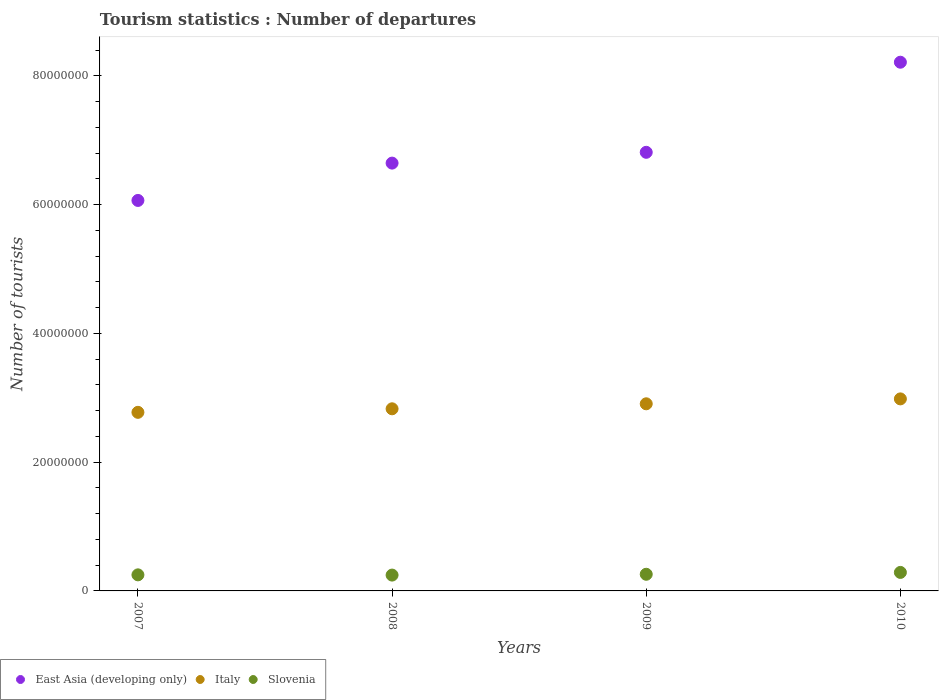How many different coloured dotlines are there?
Keep it short and to the point. 3. What is the number of tourist departures in East Asia (developing only) in 2009?
Ensure brevity in your answer.  6.81e+07. Across all years, what is the maximum number of tourist departures in Slovenia?
Your response must be concise. 2.87e+06. Across all years, what is the minimum number of tourist departures in Slovenia?
Keep it short and to the point. 2.46e+06. In which year was the number of tourist departures in Slovenia maximum?
Your answer should be compact. 2010. What is the total number of tourist departures in Slovenia in the graph?
Your answer should be very brief. 1.04e+07. What is the difference between the number of tourist departures in East Asia (developing only) in 2007 and that in 2010?
Ensure brevity in your answer.  -2.15e+07. What is the difference between the number of tourist departures in Italy in 2009 and the number of tourist departures in East Asia (developing only) in 2007?
Ensure brevity in your answer.  -3.16e+07. What is the average number of tourist departures in Italy per year?
Make the answer very short. 2.87e+07. In the year 2009, what is the difference between the number of tourist departures in East Asia (developing only) and number of tourist departures in Slovenia?
Your answer should be very brief. 6.55e+07. In how many years, is the number of tourist departures in Italy greater than 4000000?
Your response must be concise. 4. What is the ratio of the number of tourist departures in East Asia (developing only) in 2008 to that in 2009?
Offer a terse response. 0.98. Is the difference between the number of tourist departures in East Asia (developing only) in 2007 and 2008 greater than the difference between the number of tourist departures in Slovenia in 2007 and 2008?
Your answer should be very brief. No. What is the difference between the highest and the second highest number of tourist departures in Italy?
Give a very brief answer. 7.63e+05. What is the difference between the highest and the lowest number of tourist departures in East Asia (developing only)?
Your answer should be compact. 2.15e+07. In how many years, is the number of tourist departures in Italy greater than the average number of tourist departures in Italy taken over all years?
Provide a succinct answer. 2. Is the sum of the number of tourist departures in East Asia (developing only) in 2008 and 2010 greater than the maximum number of tourist departures in Italy across all years?
Offer a very short reply. Yes. Is it the case that in every year, the sum of the number of tourist departures in East Asia (developing only) and number of tourist departures in Slovenia  is greater than the number of tourist departures in Italy?
Your answer should be very brief. Yes. Is the number of tourist departures in East Asia (developing only) strictly less than the number of tourist departures in Slovenia over the years?
Your answer should be very brief. No. Where does the legend appear in the graph?
Keep it short and to the point. Bottom left. How are the legend labels stacked?
Ensure brevity in your answer.  Horizontal. What is the title of the graph?
Offer a terse response. Tourism statistics : Number of departures. Does "Fragile and conflict affected situations" appear as one of the legend labels in the graph?
Make the answer very short. No. What is the label or title of the Y-axis?
Make the answer very short. Number of tourists. What is the Number of tourists of East Asia (developing only) in 2007?
Offer a very short reply. 6.06e+07. What is the Number of tourists of Italy in 2007?
Offer a terse response. 2.77e+07. What is the Number of tourists in Slovenia in 2007?
Ensure brevity in your answer.  2.50e+06. What is the Number of tourists in East Asia (developing only) in 2008?
Your response must be concise. 6.64e+07. What is the Number of tourists in Italy in 2008?
Keep it short and to the point. 2.83e+07. What is the Number of tourists in Slovenia in 2008?
Offer a very short reply. 2.46e+06. What is the Number of tourists in East Asia (developing only) in 2009?
Offer a very short reply. 6.81e+07. What is the Number of tourists of Italy in 2009?
Keep it short and to the point. 2.91e+07. What is the Number of tourists of Slovenia in 2009?
Make the answer very short. 2.59e+06. What is the Number of tourists in East Asia (developing only) in 2010?
Your answer should be compact. 8.21e+07. What is the Number of tourists in Italy in 2010?
Provide a succinct answer. 2.98e+07. What is the Number of tourists in Slovenia in 2010?
Keep it short and to the point. 2.87e+06. Across all years, what is the maximum Number of tourists of East Asia (developing only)?
Offer a very short reply. 8.21e+07. Across all years, what is the maximum Number of tourists of Italy?
Ensure brevity in your answer.  2.98e+07. Across all years, what is the maximum Number of tourists in Slovenia?
Your answer should be very brief. 2.87e+06. Across all years, what is the minimum Number of tourists in East Asia (developing only)?
Offer a very short reply. 6.06e+07. Across all years, what is the minimum Number of tourists in Italy?
Make the answer very short. 2.77e+07. Across all years, what is the minimum Number of tourists in Slovenia?
Provide a succinct answer. 2.46e+06. What is the total Number of tourists in East Asia (developing only) in the graph?
Give a very brief answer. 2.77e+08. What is the total Number of tourists of Italy in the graph?
Provide a succinct answer. 1.15e+08. What is the total Number of tourists of Slovenia in the graph?
Offer a terse response. 1.04e+07. What is the difference between the Number of tourists in East Asia (developing only) in 2007 and that in 2008?
Your response must be concise. -5.80e+06. What is the difference between the Number of tourists in Italy in 2007 and that in 2008?
Offer a terse response. -5.50e+05. What is the difference between the Number of tourists in Slovenia in 2007 and that in 2008?
Make the answer very short. 3.70e+04. What is the difference between the Number of tourists of East Asia (developing only) in 2007 and that in 2009?
Offer a terse response. -7.47e+06. What is the difference between the Number of tourists of Italy in 2007 and that in 2009?
Your answer should be very brief. -1.33e+06. What is the difference between the Number of tourists in Slovenia in 2007 and that in 2009?
Provide a succinct answer. -9.00e+04. What is the difference between the Number of tourists of East Asia (developing only) in 2007 and that in 2010?
Offer a very short reply. -2.15e+07. What is the difference between the Number of tourists in Italy in 2007 and that in 2010?
Your answer should be compact. -2.09e+06. What is the difference between the Number of tourists of Slovenia in 2007 and that in 2010?
Offer a very short reply. -3.78e+05. What is the difference between the Number of tourists of East Asia (developing only) in 2008 and that in 2009?
Give a very brief answer. -1.68e+06. What is the difference between the Number of tourists in Italy in 2008 and that in 2009?
Your response must be concise. -7.76e+05. What is the difference between the Number of tourists in Slovenia in 2008 and that in 2009?
Ensure brevity in your answer.  -1.27e+05. What is the difference between the Number of tourists of East Asia (developing only) in 2008 and that in 2010?
Offer a very short reply. -1.57e+07. What is the difference between the Number of tourists of Italy in 2008 and that in 2010?
Your response must be concise. -1.54e+06. What is the difference between the Number of tourists of Slovenia in 2008 and that in 2010?
Your answer should be compact. -4.15e+05. What is the difference between the Number of tourists in East Asia (developing only) in 2009 and that in 2010?
Keep it short and to the point. -1.40e+07. What is the difference between the Number of tourists in Italy in 2009 and that in 2010?
Your response must be concise. -7.63e+05. What is the difference between the Number of tourists of Slovenia in 2009 and that in 2010?
Provide a succinct answer. -2.88e+05. What is the difference between the Number of tourists of East Asia (developing only) in 2007 and the Number of tourists of Italy in 2008?
Offer a terse response. 3.24e+07. What is the difference between the Number of tourists of East Asia (developing only) in 2007 and the Number of tourists of Slovenia in 2008?
Provide a succinct answer. 5.82e+07. What is the difference between the Number of tourists of Italy in 2007 and the Number of tourists of Slovenia in 2008?
Your answer should be compact. 2.53e+07. What is the difference between the Number of tourists in East Asia (developing only) in 2007 and the Number of tourists in Italy in 2009?
Offer a very short reply. 3.16e+07. What is the difference between the Number of tourists in East Asia (developing only) in 2007 and the Number of tourists in Slovenia in 2009?
Offer a very short reply. 5.81e+07. What is the difference between the Number of tourists in Italy in 2007 and the Number of tourists in Slovenia in 2009?
Ensure brevity in your answer.  2.51e+07. What is the difference between the Number of tourists of East Asia (developing only) in 2007 and the Number of tourists of Italy in 2010?
Keep it short and to the point. 3.08e+07. What is the difference between the Number of tourists in East Asia (developing only) in 2007 and the Number of tourists in Slovenia in 2010?
Give a very brief answer. 5.78e+07. What is the difference between the Number of tourists in Italy in 2007 and the Number of tourists in Slovenia in 2010?
Offer a very short reply. 2.49e+07. What is the difference between the Number of tourists of East Asia (developing only) in 2008 and the Number of tourists of Italy in 2009?
Provide a succinct answer. 3.74e+07. What is the difference between the Number of tourists in East Asia (developing only) in 2008 and the Number of tourists in Slovenia in 2009?
Your answer should be compact. 6.39e+07. What is the difference between the Number of tourists in Italy in 2008 and the Number of tourists in Slovenia in 2009?
Give a very brief answer. 2.57e+07. What is the difference between the Number of tourists of East Asia (developing only) in 2008 and the Number of tourists of Italy in 2010?
Offer a terse response. 3.66e+07. What is the difference between the Number of tourists in East Asia (developing only) in 2008 and the Number of tourists in Slovenia in 2010?
Your answer should be very brief. 6.36e+07. What is the difference between the Number of tourists in Italy in 2008 and the Number of tourists in Slovenia in 2010?
Your answer should be compact. 2.54e+07. What is the difference between the Number of tourists of East Asia (developing only) in 2009 and the Number of tourists of Italy in 2010?
Your response must be concise. 3.83e+07. What is the difference between the Number of tourists of East Asia (developing only) in 2009 and the Number of tourists of Slovenia in 2010?
Provide a short and direct response. 6.52e+07. What is the difference between the Number of tourists of Italy in 2009 and the Number of tourists of Slovenia in 2010?
Your answer should be compact. 2.62e+07. What is the average Number of tourists in East Asia (developing only) per year?
Give a very brief answer. 6.93e+07. What is the average Number of tourists in Italy per year?
Your answer should be very brief. 2.87e+07. What is the average Number of tourists in Slovenia per year?
Offer a terse response. 2.60e+06. In the year 2007, what is the difference between the Number of tourists of East Asia (developing only) and Number of tourists of Italy?
Keep it short and to the point. 3.29e+07. In the year 2007, what is the difference between the Number of tourists in East Asia (developing only) and Number of tourists in Slovenia?
Offer a terse response. 5.81e+07. In the year 2007, what is the difference between the Number of tourists of Italy and Number of tourists of Slovenia?
Offer a terse response. 2.52e+07. In the year 2008, what is the difference between the Number of tourists of East Asia (developing only) and Number of tourists of Italy?
Your response must be concise. 3.82e+07. In the year 2008, what is the difference between the Number of tourists of East Asia (developing only) and Number of tourists of Slovenia?
Provide a short and direct response. 6.40e+07. In the year 2008, what is the difference between the Number of tourists of Italy and Number of tourists of Slovenia?
Give a very brief answer. 2.58e+07. In the year 2009, what is the difference between the Number of tourists in East Asia (developing only) and Number of tourists in Italy?
Give a very brief answer. 3.91e+07. In the year 2009, what is the difference between the Number of tourists of East Asia (developing only) and Number of tourists of Slovenia?
Your response must be concise. 6.55e+07. In the year 2009, what is the difference between the Number of tourists of Italy and Number of tourists of Slovenia?
Provide a succinct answer. 2.65e+07. In the year 2010, what is the difference between the Number of tourists of East Asia (developing only) and Number of tourists of Italy?
Your answer should be compact. 5.23e+07. In the year 2010, what is the difference between the Number of tourists in East Asia (developing only) and Number of tourists in Slovenia?
Give a very brief answer. 7.92e+07. In the year 2010, what is the difference between the Number of tourists in Italy and Number of tourists in Slovenia?
Keep it short and to the point. 2.69e+07. What is the ratio of the Number of tourists in East Asia (developing only) in 2007 to that in 2008?
Offer a very short reply. 0.91. What is the ratio of the Number of tourists of Italy in 2007 to that in 2008?
Offer a very short reply. 0.98. What is the ratio of the Number of tourists in Slovenia in 2007 to that in 2008?
Your answer should be compact. 1.01. What is the ratio of the Number of tourists of East Asia (developing only) in 2007 to that in 2009?
Give a very brief answer. 0.89. What is the ratio of the Number of tourists in Italy in 2007 to that in 2009?
Your response must be concise. 0.95. What is the ratio of the Number of tourists of Slovenia in 2007 to that in 2009?
Your response must be concise. 0.97. What is the ratio of the Number of tourists in East Asia (developing only) in 2007 to that in 2010?
Your answer should be very brief. 0.74. What is the ratio of the Number of tourists of Slovenia in 2007 to that in 2010?
Offer a very short reply. 0.87. What is the ratio of the Number of tourists of East Asia (developing only) in 2008 to that in 2009?
Ensure brevity in your answer.  0.98. What is the ratio of the Number of tourists in Italy in 2008 to that in 2009?
Provide a short and direct response. 0.97. What is the ratio of the Number of tourists in Slovenia in 2008 to that in 2009?
Your response must be concise. 0.95. What is the ratio of the Number of tourists of East Asia (developing only) in 2008 to that in 2010?
Your answer should be compact. 0.81. What is the ratio of the Number of tourists in Italy in 2008 to that in 2010?
Offer a very short reply. 0.95. What is the ratio of the Number of tourists in Slovenia in 2008 to that in 2010?
Keep it short and to the point. 0.86. What is the ratio of the Number of tourists in East Asia (developing only) in 2009 to that in 2010?
Provide a succinct answer. 0.83. What is the ratio of the Number of tourists of Italy in 2009 to that in 2010?
Provide a short and direct response. 0.97. What is the ratio of the Number of tourists in Slovenia in 2009 to that in 2010?
Offer a terse response. 0.9. What is the difference between the highest and the second highest Number of tourists of East Asia (developing only)?
Offer a terse response. 1.40e+07. What is the difference between the highest and the second highest Number of tourists in Italy?
Keep it short and to the point. 7.63e+05. What is the difference between the highest and the second highest Number of tourists of Slovenia?
Ensure brevity in your answer.  2.88e+05. What is the difference between the highest and the lowest Number of tourists of East Asia (developing only)?
Give a very brief answer. 2.15e+07. What is the difference between the highest and the lowest Number of tourists of Italy?
Offer a terse response. 2.09e+06. What is the difference between the highest and the lowest Number of tourists in Slovenia?
Your answer should be very brief. 4.15e+05. 